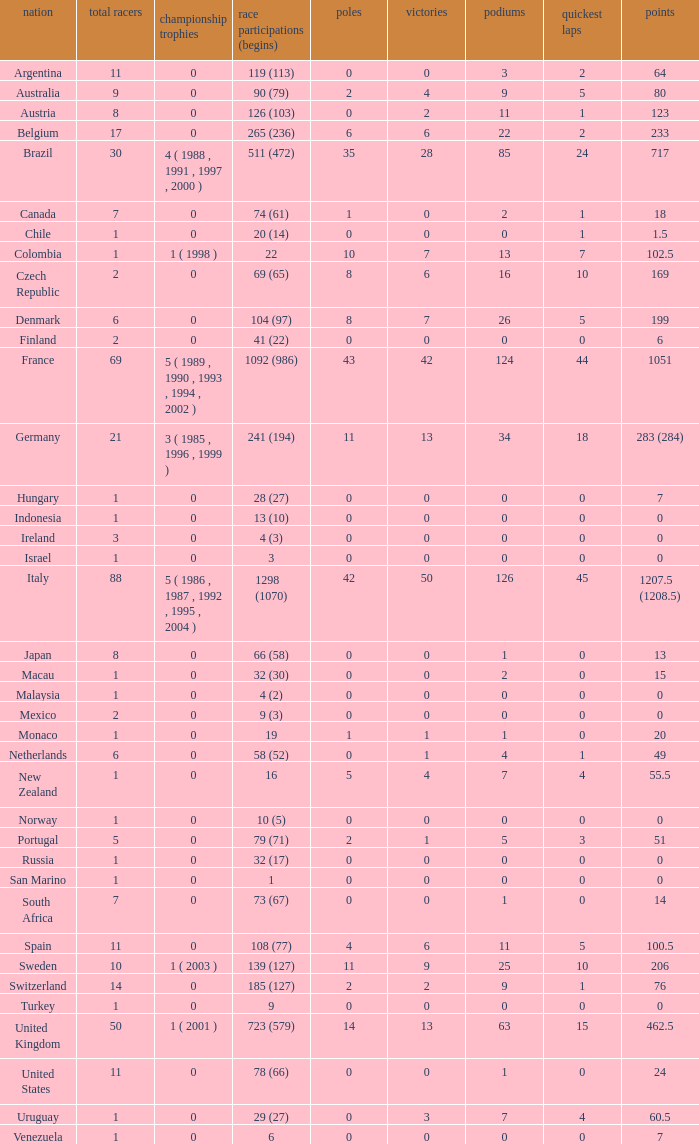How many fastest laps for the nation with 32 (30) entries and starts and fewer than 2 podiums? None. 